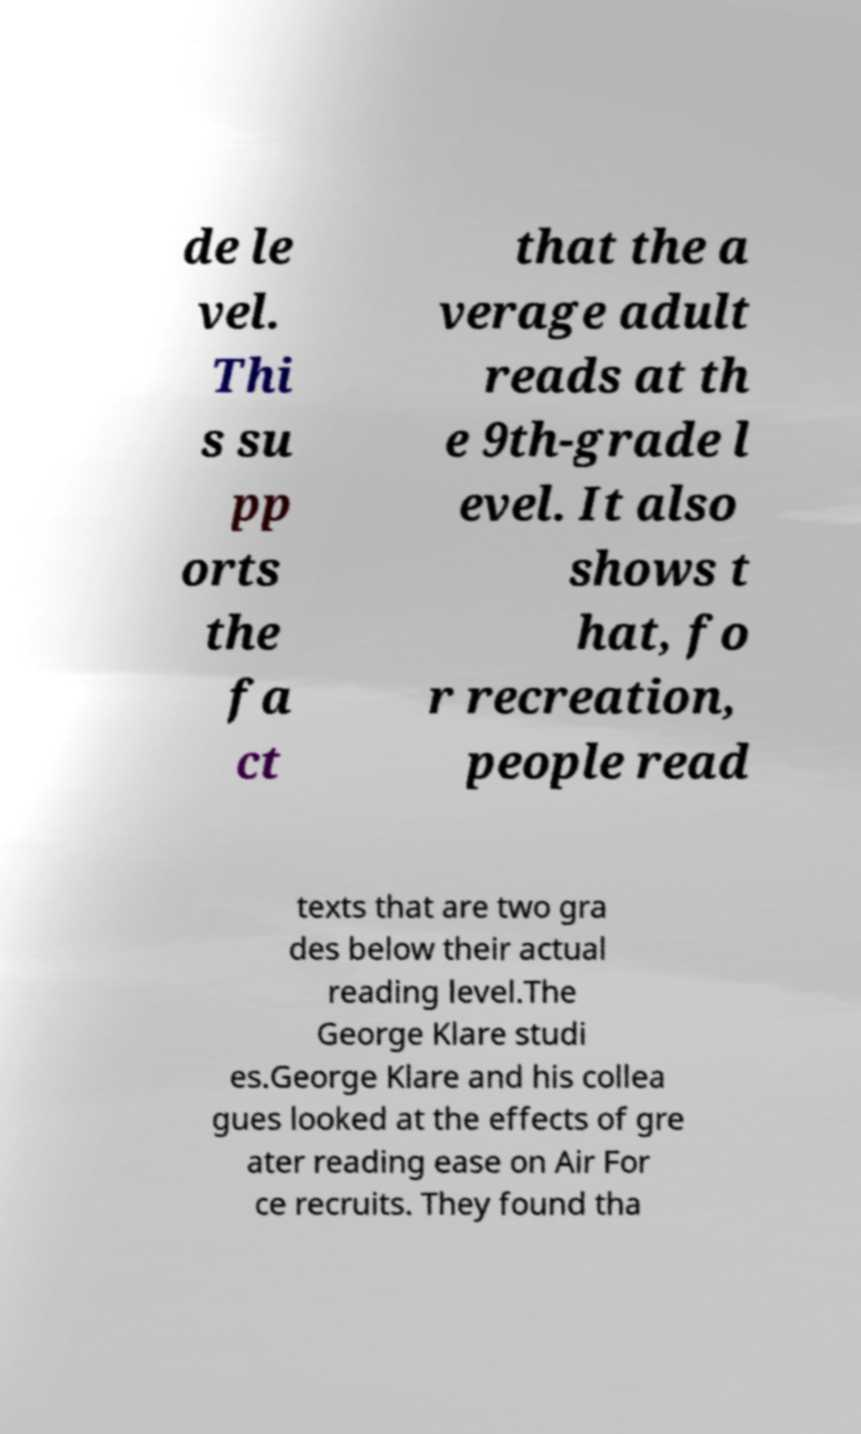Can you accurately transcribe the text from the provided image for me? de le vel. Thi s su pp orts the fa ct that the a verage adult reads at th e 9th-grade l evel. It also shows t hat, fo r recreation, people read texts that are two gra des below their actual reading level.The George Klare studi es.George Klare and his collea gues looked at the effects of gre ater reading ease on Air For ce recruits. They found tha 